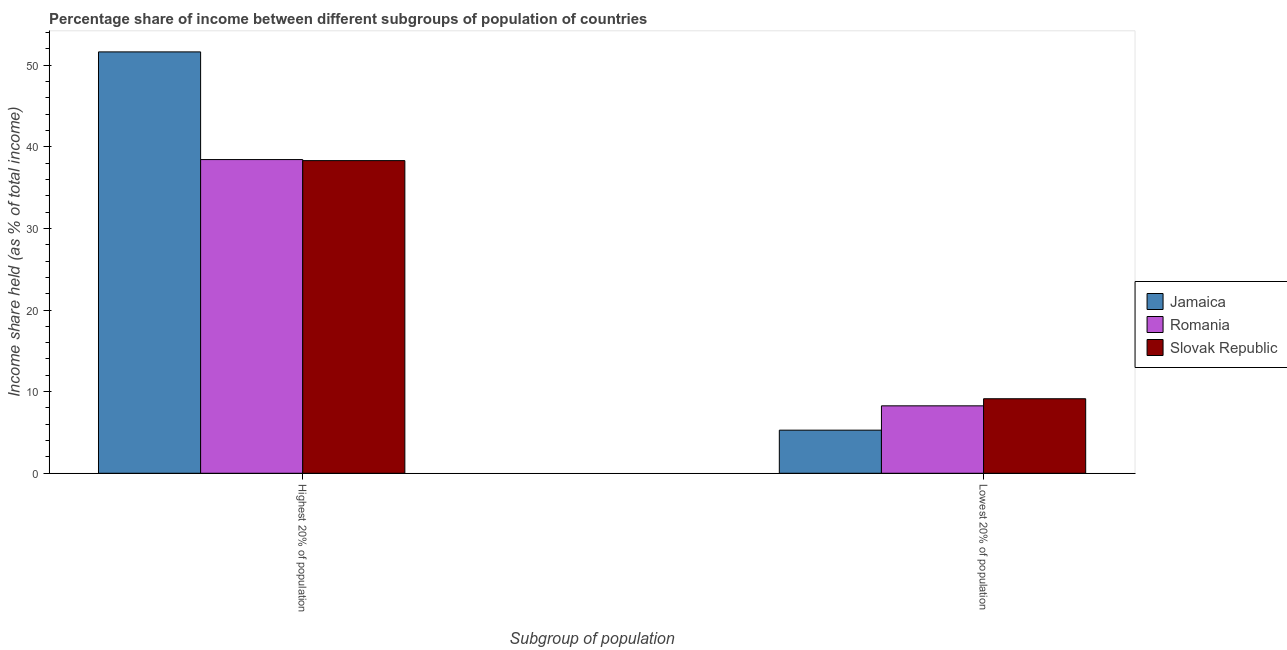Are the number of bars on each tick of the X-axis equal?
Offer a terse response. Yes. What is the label of the 1st group of bars from the left?
Provide a short and direct response. Highest 20% of population. What is the income share held by highest 20% of the population in Slovak Republic?
Offer a very short reply. 38.3. Across all countries, what is the maximum income share held by highest 20% of the population?
Your answer should be compact. 51.62. Across all countries, what is the minimum income share held by highest 20% of the population?
Give a very brief answer. 38.3. In which country was the income share held by lowest 20% of the population maximum?
Your answer should be very brief. Slovak Republic. In which country was the income share held by lowest 20% of the population minimum?
Your answer should be compact. Jamaica. What is the total income share held by lowest 20% of the population in the graph?
Keep it short and to the point. 22.67. What is the difference between the income share held by highest 20% of the population in Romania and that in Jamaica?
Offer a terse response. -13.19. What is the difference between the income share held by lowest 20% of the population in Jamaica and the income share held by highest 20% of the population in Romania?
Ensure brevity in your answer.  -33.15. What is the average income share held by lowest 20% of the population per country?
Ensure brevity in your answer.  7.56. What is the difference between the income share held by highest 20% of the population and income share held by lowest 20% of the population in Slovak Republic?
Keep it short and to the point. 29.17. In how many countries, is the income share held by highest 20% of the population greater than 20 %?
Provide a succinct answer. 3. What is the ratio of the income share held by lowest 20% of the population in Romania to that in Slovak Republic?
Offer a terse response. 0.9. In how many countries, is the income share held by highest 20% of the population greater than the average income share held by highest 20% of the population taken over all countries?
Make the answer very short. 1. What does the 3rd bar from the left in Highest 20% of population represents?
Your answer should be compact. Slovak Republic. What does the 2nd bar from the right in Lowest 20% of population represents?
Your answer should be very brief. Romania. How many bars are there?
Provide a short and direct response. 6. How many countries are there in the graph?
Offer a very short reply. 3. What is the difference between two consecutive major ticks on the Y-axis?
Ensure brevity in your answer.  10. Are the values on the major ticks of Y-axis written in scientific E-notation?
Your answer should be compact. No. Does the graph contain any zero values?
Offer a terse response. No. How are the legend labels stacked?
Offer a terse response. Vertical. What is the title of the graph?
Offer a very short reply. Percentage share of income between different subgroups of population of countries. Does "Uruguay" appear as one of the legend labels in the graph?
Offer a terse response. No. What is the label or title of the X-axis?
Keep it short and to the point. Subgroup of population. What is the label or title of the Y-axis?
Your answer should be compact. Income share held (as % of total income). What is the Income share held (as % of total income) of Jamaica in Highest 20% of population?
Give a very brief answer. 51.62. What is the Income share held (as % of total income) of Romania in Highest 20% of population?
Provide a short and direct response. 38.43. What is the Income share held (as % of total income) in Slovak Republic in Highest 20% of population?
Ensure brevity in your answer.  38.3. What is the Income share held (as % of total income) in Jamaica in Lowest 20% of population?
Provide a succinct answer. 5.28. What is the Income share held (as % of total income) in Romania in Lowest 20% of population?
Your response must be concise. 8.26. What is the Income share held (as % of total income) in Slovak Republic in Lowest 20% of population?
Give a very brief answer. 9.13. Across all Subgroup of population, what is the maximum Income share held (as % of total income) in Jamaica?
Your answer should be compact. 51.62. Across all Subgroup of population, what is the maximum Income share held (as % of total income) of Romania?
Your answer should be compact. 38.43. Across all Subgroup of population, what is the maximum Income share held (as % of total income) in Slovak Republic?
Offer a very short reply. 38.3. Across all Subgroup of population, what is the minimum Income share held (as % of total income) in Jamaica?
Provide a short and direct response. 5.28. Across all Subgroup of population, what is the minimum Income share held (as % of total income) in Romania?
Offer a terse response. 8.26. Across all Subgroup of population, what is the minimum Income share held (as % of total income) in Slovak Republic?
Provide a succinct answer. 9.13. What is the total Income share held (as % of total income) of Jamaica in the graph?
Provide a short and direct response. 56.9. What is the total Income share held (as % of total income) in Romania in the graph?
Your answer should be very brief. 46.69. What is the total Income share held (as % of total income) in Slovak Republic in the graph?
Provide a short and direct response. 47.43. What is the difference between the Income share held (as % of total income) in Jamaica in Highest 20% of population and that in Lowest 20% of population?
Ensure brevity in your answer.  46.34. What is the difference between the Income share held (as % of total income) in Romania in Highest 20% of population and that in Lowest 20% of population?
Ensure brevity in your answer.  30.17. What is the difference between the Income share held (as % of total income) in Slovak Republic in Highest 20% of population and that in Lowest 20% of population?
Give a very brief answer. 29.17. What is the difference between the Income share held (as % of total income) in Jamaica in Highest 20% of population and the Income share held (as % of total income) in Romania in Lowest 20% of population?
Your answer should be compact. 43.36. What is the difference between the Income share held (as % of total income) of Jamaica in Highest 20% of population and the Income share held (as % of total income) of Slovak Republic in Lowest 20% of population?
Your response must be concise. 42.49. What is the difference between the Income share held (as % of total income) in Romania in Highest 20% of population and the Income share held (as % of total income) in Slovak Republic in Lowest 20% of population?
Offer a terse response. 29.3. What is the average Income share held (as % of total income) of Jamaica per Subgroup of population?
Offer a very short reply. 28.45. What is the average Income share held (as % of total income) in Romania per Subgroup of population?
Give a very brief answer. 23.34. What is the average Income share held (as % of total income) in Slovak Republic per Subgroup of population?
Ensure brevity in your answer.  23.71. What is the difference between the Income share held (as % of total income) in Jamaica and Income share held (as % of total income) in Romania in Highest 20% of population?
Give a very brief answer. 13.19. What is the difference between the Income share held (as % of total income) in Jamaica and Income share held (as % of total income) in Slovak Republic in Highest 20% of population?
Offer a very short reply. 13.32. What is the difference between the Income share held (as % of total income) of Romania and Income share held (as % of total income) of Slovak Republic in Highest 20% of population?
Offer a very short reply. 0.13. What is the difference between the Income share held (as % of total income) of Jamaica and Income share held (as % of total income) of Romania in Lowest 20% of population?
Offer a very short reply. -2.98. What is the difference between the Income share held (as % of total income) of Jamaica and Income share held (as % of total income) of Slovak Republic in Lowest 20% of population?
Keep it short and to the point. -3.85. What is the difference between the Income share held (as % of total income) of Romania and Income share held (as % of total income) of Slovak Republic in Lowest 20% of population?
Ensure brevity in your answer.  -0.87. What is the ratio of the Income share held (as % of total income) in Jamaica in Highest 20% of population to that in Lowest 20% of population?
Your answer should be compact. 9.78. What is the ratio of the Income share held (as % of total income) in Romania in Highest 20% of population to that in Lowest 20% of population?
Provide a succinct answer. 4.65. What is the ratio of the Income share held (as % of total income) in Slovak Republic in Highest 20% of population to that in Lowest 20% of population?
Ensure brevity in your answer.  4.2. What is the difference between the highest and the second highest Income share held (as % of total income) in Jamaica?
Your response must be concise. 46.34. What is the difference between the highest and the second highest Income share held (as % of total income) of Romania?
Give a very brief answer. 30.17. What is the difference between the highest and the second highest Income share held (as % of total income) of Slovak Republic?
Provide a succinct answer. 29.17. What is the difference between the highest and the lowest Income share held (as % of total income) of Jamaica?
Offer a very short reply. 46.34. What is the difference between the highest and the lowest Income share held (as % of total income) in Romania?
Offer a terse response. 30.17. What is the difference between the highest and the lowest Income share held (as % of total income) in Slovak Republic?
Offer a terse response. 29.17. 